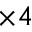<formula> <loc_0><loc_0><loc_500><loc_500>\times 4</formula> 